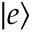Convert formula to latex. <formula><loc_0><loc_0><loc_500><loc_500>| e \rangle</formula> 